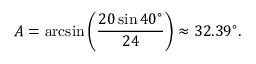Convert formula to latex. <formula><loc_0><loc_0><loc_500><loc_500>A = \arcsin \left ( { \frac { 2 0 \sin 4 0 ^ { \circ } } { 2 4 } } \right ) \approx 3 2 . 3 9 ^ { \circ } .</formula> 